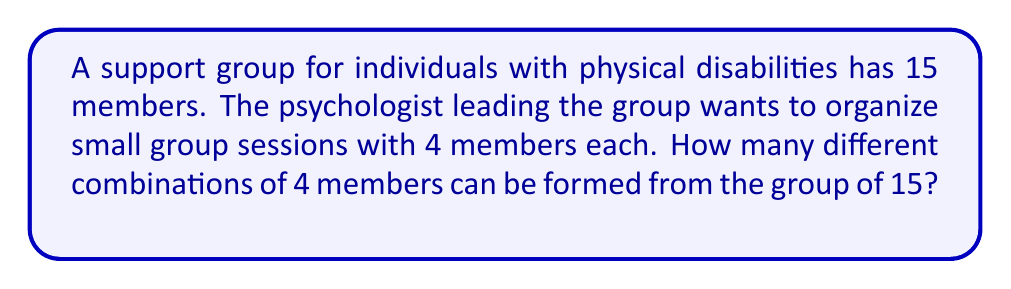Give your solution to this math problem. To solve this problem, we need to use the combination formula. We are selecting 4 members from a group of 15, where the order doesn't matter (as it's a group session, not an ordered list).

The formula for combinations is:

$${n \choose k} = \frac{n!}{k!(n-k)!}$$

Where:
$n$ is the total number of items to choose from (in this case, 15 group members)
$k$ is the number of items being chosen (in this case, 4 members for each small group)

Let's substitute our values:

$${15 \choose 4} = \frac{15!}{4!(15-4)!} = \frac{15!}{4!11!}$$

Now, let's calculate this step-by-step:

1) $15! = 1,307,674,368,000$
2) $4! = 24$
3) $11! = 39,916,800$

Substituting these values:

$$\frac{1,307,674,368,000}{24 \times 39,916,800}$$

Simplifying:

$$\frac{1,307,674,368,000}{957,993,600} = 1,365$$

Therefore, there are 1,365 different possible combinations of 4 members that can be formed from the group of 15.
Answer: 1,365 combinations 